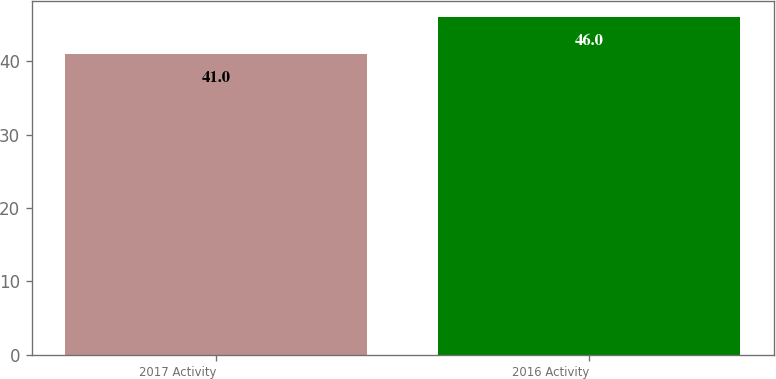<chart> <loc_0><loc_0><loc_500><loc_500><bar_chart><fcel>2017 Activity<fcel>2016 Activity<nl><fcel>41<fcel>46<nl></chart> 